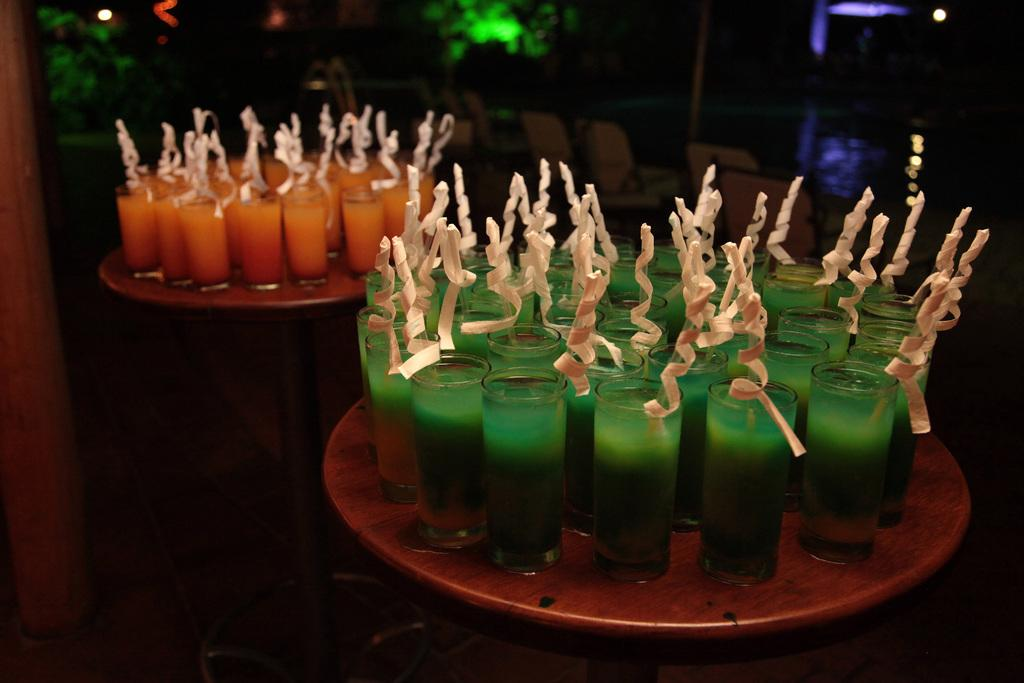What is in the glasses that are visible in the image? There are drinks in the glasses that are visible in the image. Where are the glasses placed in the image? The glasses are placed on tables in the image. What can be seen in the background of the image? There are chairs and other unspecified objects in the background of the image. What type of ring can be seen on the table in the image? There is no ring present on the table in the image. What sense is being stimulated by the objects in the image? The image does not provide information about which sense is being stimulated by the objects. 